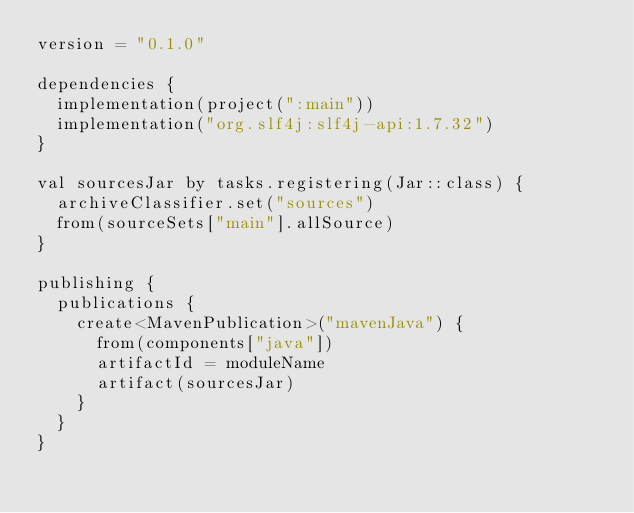Convert code to text. <code><loc_0><loc_0><loc_500><loc_500><_Kotlin_>version = "0.1.0"

dependencies {
  implementation(project(":main"))
  implementation("org.slf4j:slf4j-api:1.7.32")
}

val sourcesJar by tasks.registering(Jar::class) {
  archiveClassifier.set("sources")
  from(sourceSets["main"].allSource)
}

publishing {
  publications {
    create<MavenPublication>("mavenJava") {
      from(components["java"])
      artifactId = moduleName
      artifact(sourcesJar)
    }
  }
}
</code> 